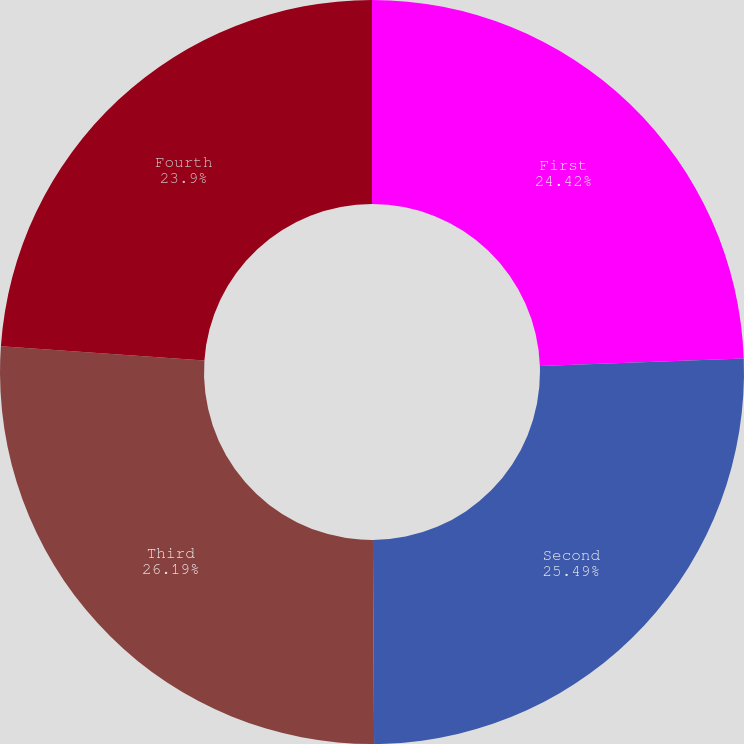<chart> <loc_0><loc_0><loc_500><loc_500><pie_chart><fcel>First<fcel>Second<fcel>Third<fcel>Fourth<nl><fcel>24.42%<fcel>25.49%<fcel>26.19%<fcel>23.9%<nl></chart> 